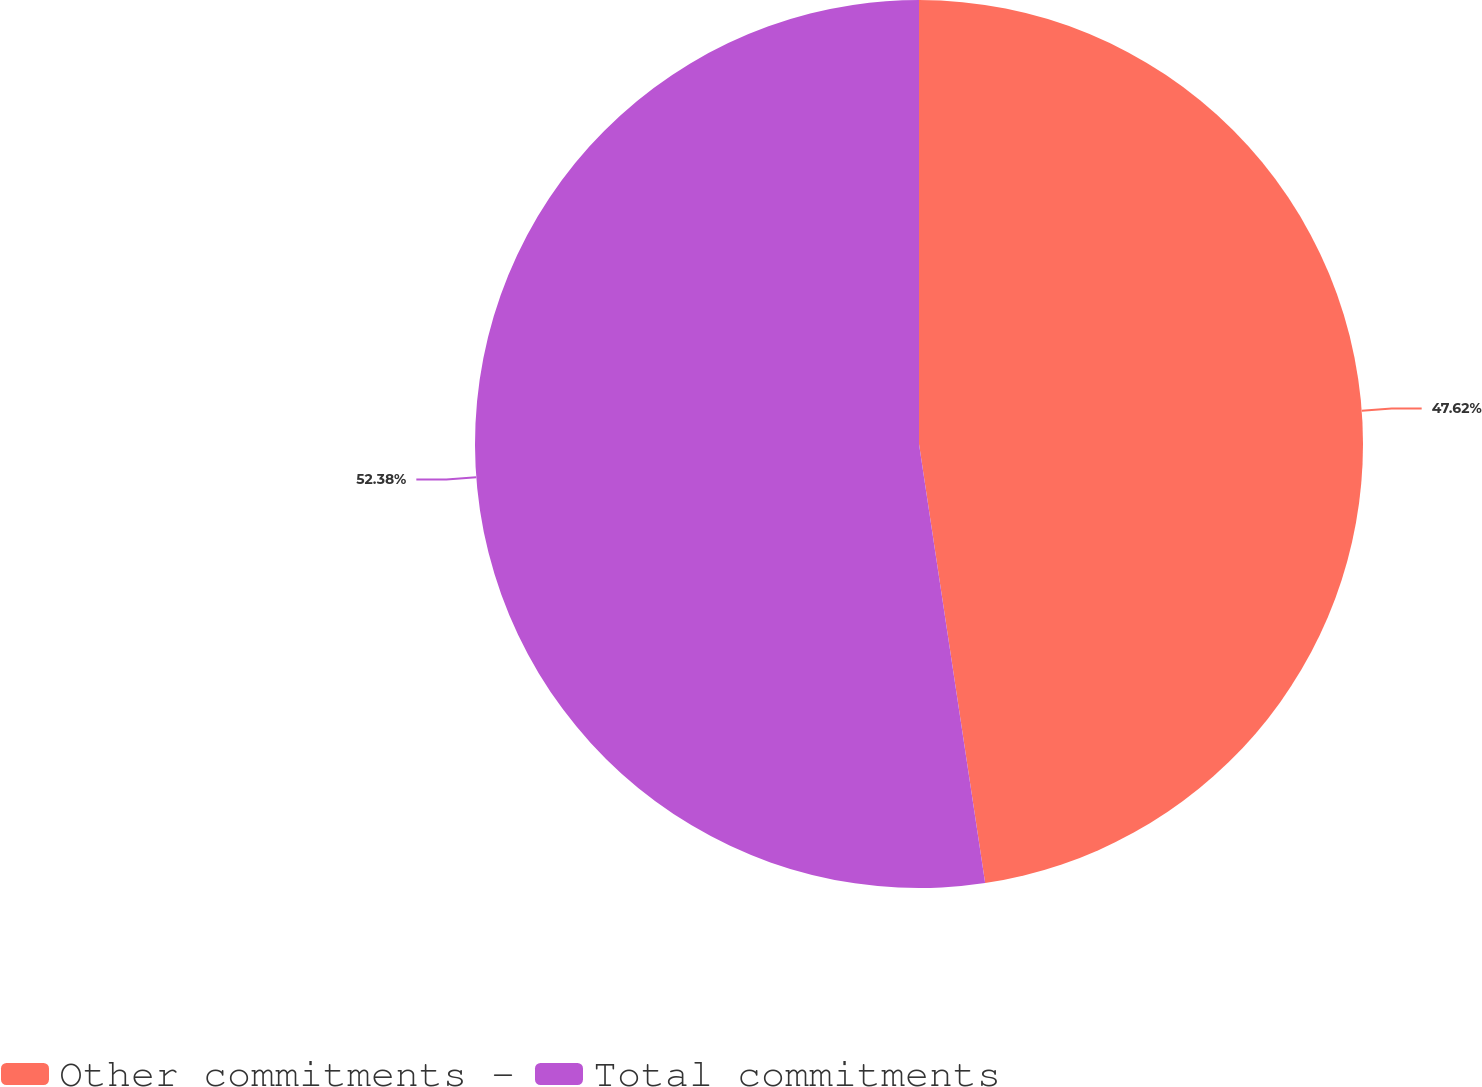<chart> <loc_0><loc_0><loc_500><loc_500><pie_chart><fcel>Other commitments -<fcel>Total commitments<nl><fcel>47.62%<fcel>52.38%<nl></chart> 